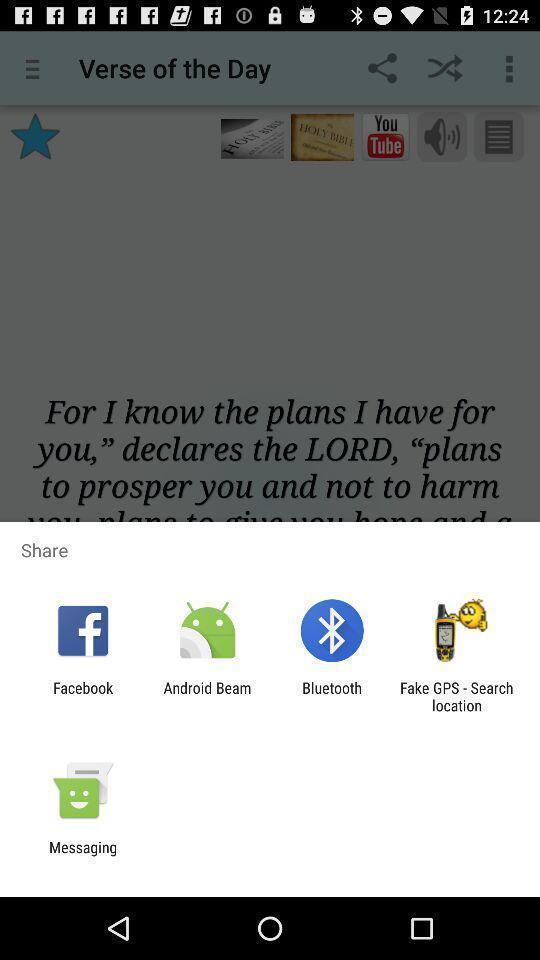Explain the elements present in this screenshot. Popup of applications to share the information. 